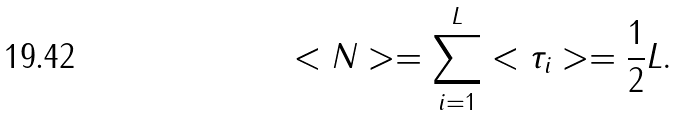<formula> <loc_0><loc_0><loc_500><loc_500>< N > = \sum _ { i = 1 } ^ { L } < \tau _ { i } > = \frac { 1 } { 2 } L .</formula> 